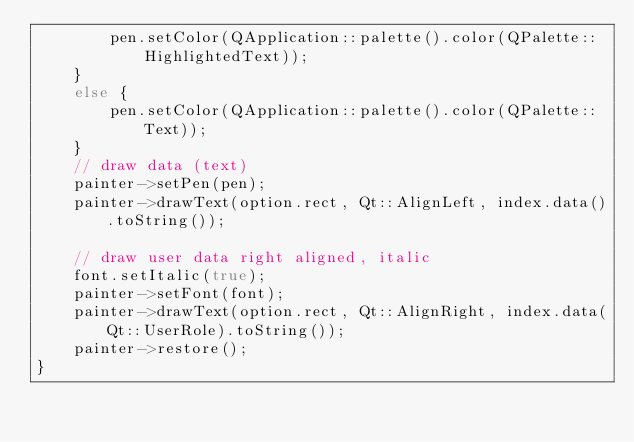Convert code to text. <code><loc_0><loc_0><loc_500><loc_500><_C++_>        pen.setColor(QApplication::palette().color(QPalette::HighlightedText));
    }
    else {
        pen.setColor(QApplication::palette().color(QPalette::Text));
    }
    // draw data (text)
    painter->setPen(pen);
    painter->drawText(option.rect, Qt::AlignLeft, index.data().toString());

    // draw user data right aligned, italic
    font.setItalic(true);
    painter->setFont(font);
    painter->drawText(option.rect, Qt::AlignRight, index.data(Qt::UserRole).toString());
    painter->restore();
}

</code> 